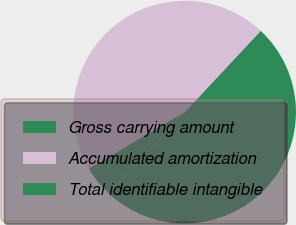<chart> <loc_0><loc_0><loc_500><loc_500><pie_chart><fcel>Gross carrying amount<fcel>Accumulated amortization<fcel>Total identifiable intangible<nl><fcel>50.01%<fcel>45.46%<fcel>4.53%<nl></chart> 